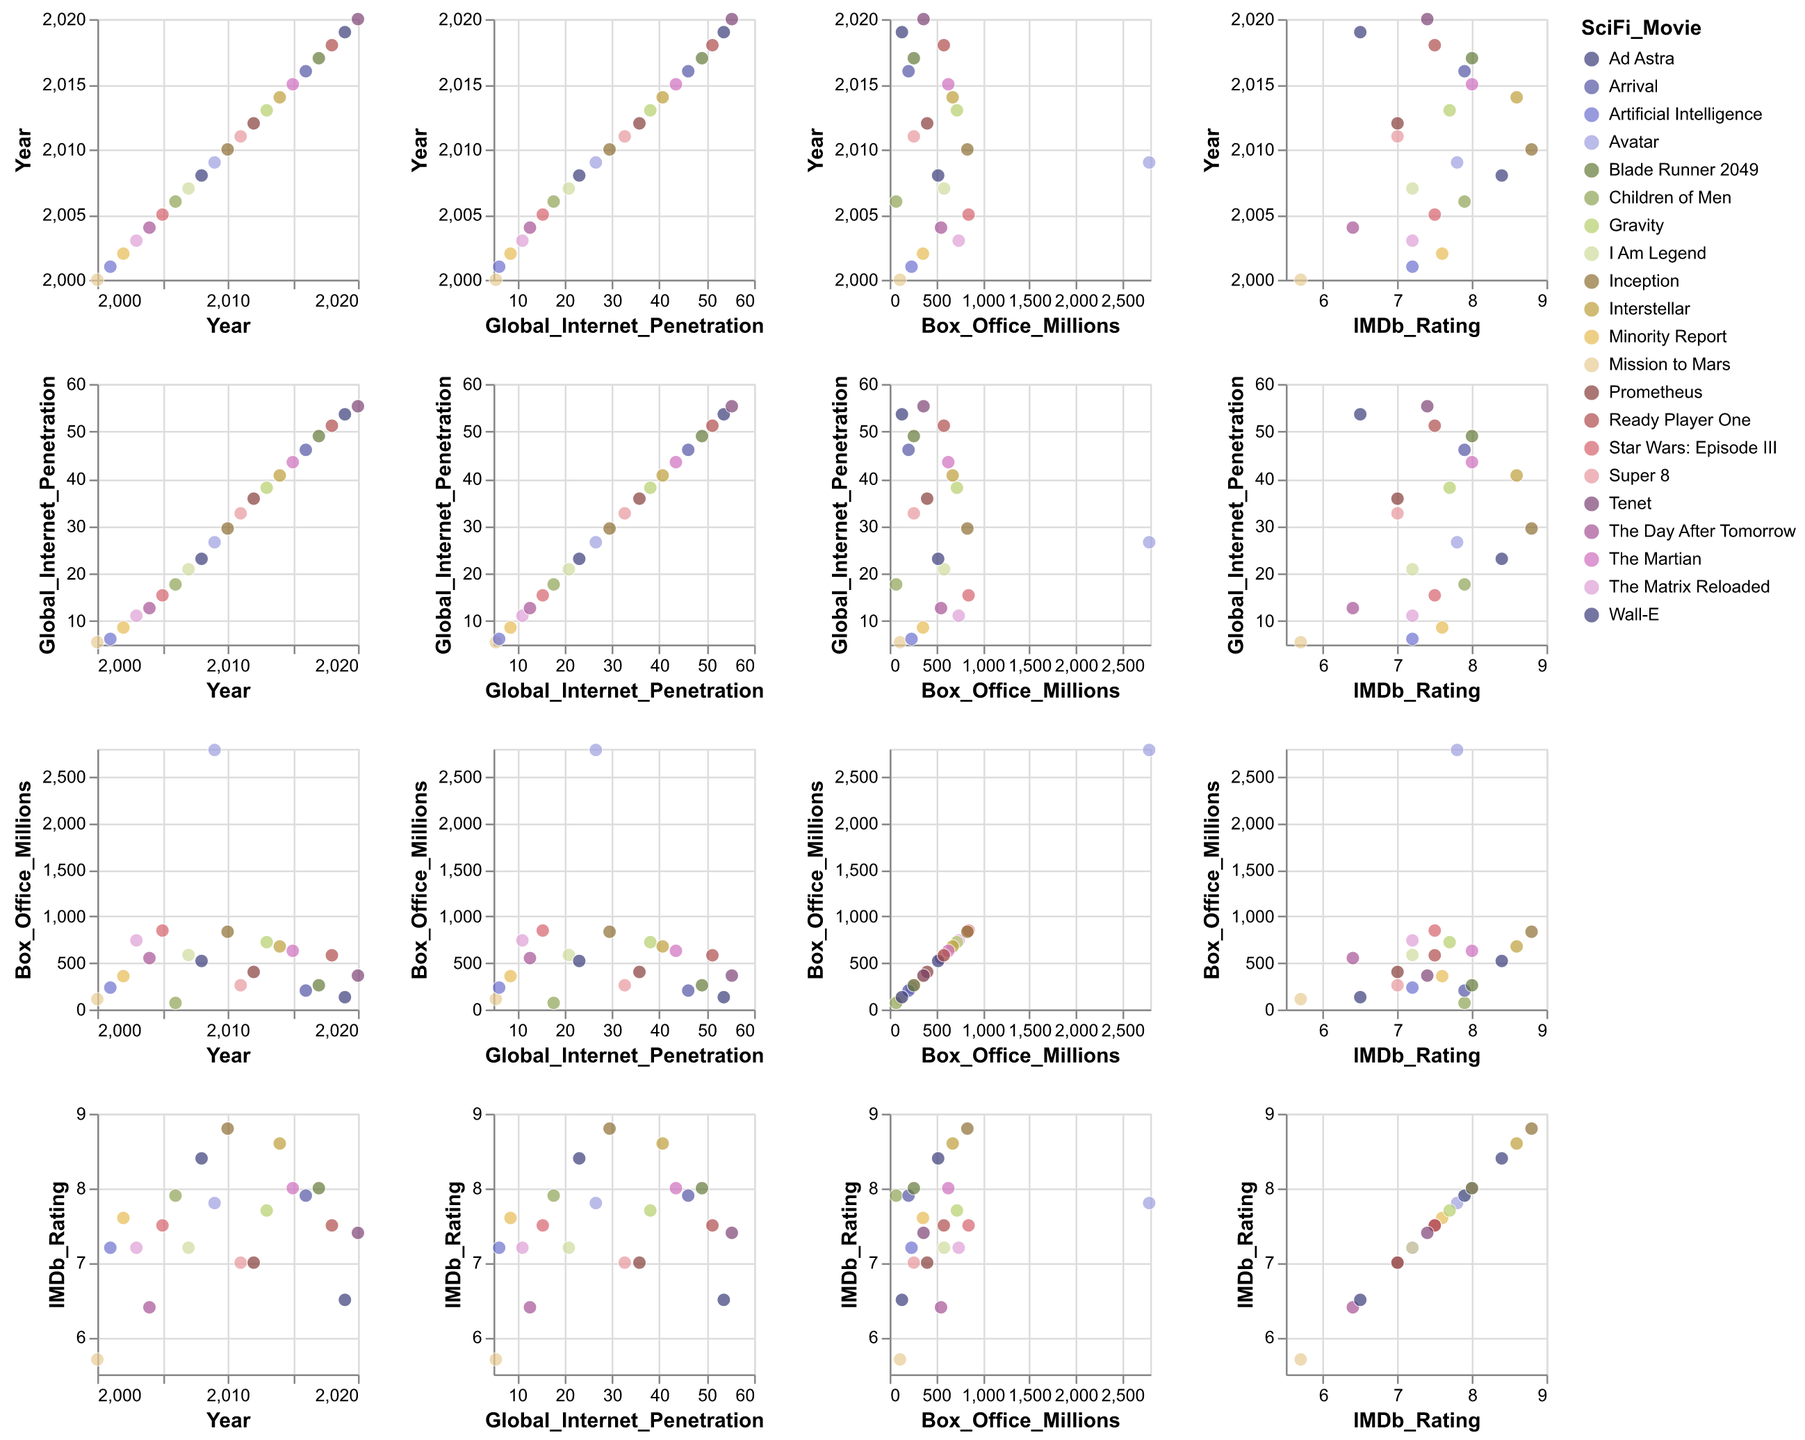How does Global Internet Penetration change over the years? Observing the SPLOM, you can see a general upward trend in the Global Internet Penetration from 2000 to 2020. Each year has a higher penetration rate compared to the previous year, indicating growing internet access globally.
Answer: It increases What is the relation between Box Office earnings and IMDb Rating for these sci-fi movies? By examining the scatter plots comparing Box Office earnings and IMDb Ratings, we can see that movies with high Box Office earnings do not always have the highest IMDb Ratings. There is no clear direct correlation between the two; some highly-rated movies have moderate earnings and vice versa.
Answer: No clear direct correlation Which sci-fi movie has the highest Box Office earnings and what is its IMDb Rating? Look at the scatter plot with Box Office earnings and identify the highest point. The tooltip shows it corresponds to the movie "Avatar" with an IMDb Rating of 7.8.
Answer: Avatar, 7.8 Does higher Global Internet Penetration relate to higher IMDb Ratings for sci-fi movies? One can compare scatter plots of Global Internet Penetration vs. IMDb Ratings. It reveals that variations in IMDb ratings are not necessarily aligned with higher internet penetration, suggesting no strong correlation. Some high-rated movies were released when internet penetration was lower.
Answer: No strong correlation Which year had the highest IMDb Rating for a sci-fi movie, and what was the movie? Look at the scatter plot of Year vs. IMDb Rating and find the highest point. The tooltip will show the year and the movie, indicating "Inception" in 2010 holds the highest rating of 8.8.
Answer: 2010, Inception Are there more high Box Office earning movies as Global Internet Penetration increases? Review the scatter plots comparing Global Internet Penetration and Box Office earnings. While higher penetration seems to coincide with some high Box Office earnings, the appearances of high-earner outliers like "Avatar" suggest it’s not a uniform trend.
Answer: Not uniform How does the trend of Box Office earnings look over the years for sci-fi movies? By viewing the scatter plot matrix, we see that while there are fluctuations, some of the highest-grossing sci-fi movies such as "Avatar" and "Star Wars: Episode III" appear towards the mid-years. The trend appears variable with peaks and drops.
Answer: Variable with peaks and drops Which year had the lowest Box Office earnings for a sci-fi movie and which movie was it? Refer to the Year vs. Box Office earnings plot and find the lowest point. The tooltip shows "Children of Men" in 2006 as the movie with the lowest earnings.
Answer: 2006, Children of Men How does the correlation between Year and Global Internet Penetration compare to the correlation between Year and Box Office earnings? Compare the scatter plots for Year vs. Global Internet Penetration and Year vs. Box Office earnings. You will notice a consistent rise in Internet Penetration over the years, which shows a strong positive trend, while Box Office earnings show a more erratic pattern with no clear consistent trend.
Answer: Strong positive for Internet Penetration, erratic for Box Office earnings 